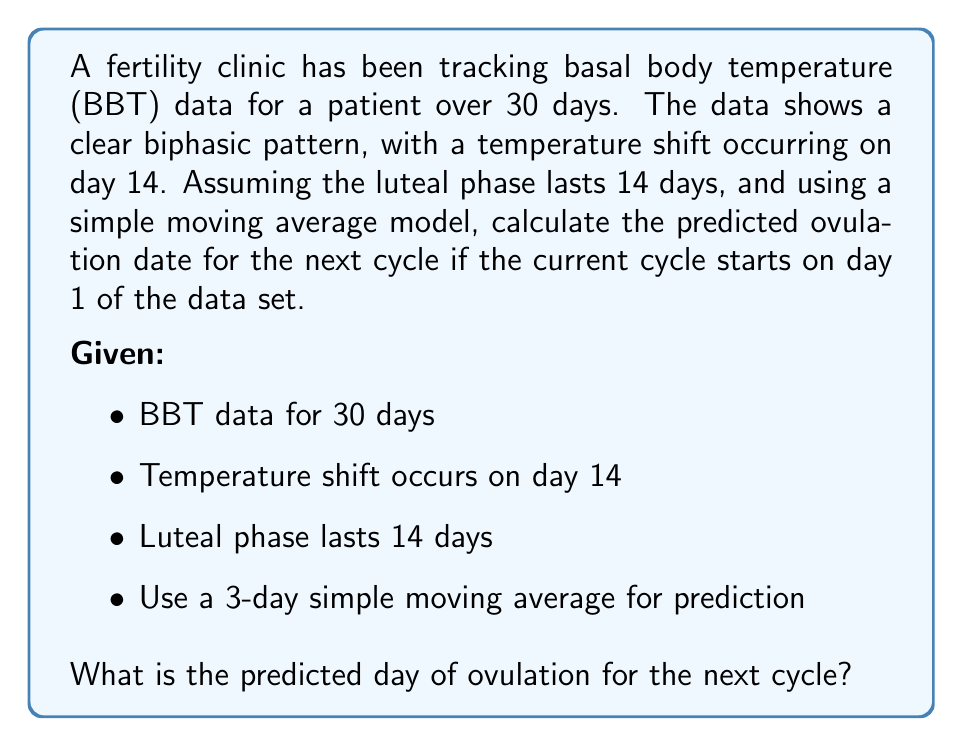What is the answer to this math problem? To solve this problem, we need to follow these steps:

1. Identify the current cycle length:
   The cycle length is the sum of the follicular phase and the luteal phase.
   Follicular phase = 14 days (until temperature shift)
   Luteal phase = 14 days (given)
   Current cycle length = 14 + 14 = 28 days

2. Calculate the 3-day simple moving average (SMA) for the last 3 days of the cycle:
   Let's assume the last 3 days' BBT readings are $T_{26}$, $T_{27}$, and $T_{28}$.
   
   $SMA = \frac{T_{26} + T_{27} + T_{28}}{3}$

3. Use the SMA to predict the next cycle's ovulation:
   The predicted ovulation day will be 14 days before the end of the next cycle.
   
   Next cycle end = Current cycle length + SMA
   Predicted ovulation day = Next cycle end - 14

4. Adjust the prediction to start from day 1 of the current cycle:
   Since we want to express the ovulation day in terms of days from the start of the current cycle, we need to add the current cycle length.

   Final predicted ovulation day = (Next cycle end - 14) + Current cycle length

Putting it all together:

$$\text{Predicted ovulation day} = (28 + \frac{T_{26} + T_{27} + T_{28}}{3} - 14) + 28$$

$$= 42 + \frac{T_{26} + T_{27} + T_{28}}{3}$$

This formula gives us the predicted ovulation day for the next cycle, counting from day 1 of the current cycle.
Answer: The predicted day of ovulation for the next cycle is:

$$42 + \frac{T_{26} + T_{27} + T_{28}}{3}$$

days from the start of the current cycle, where $T_{26}$, $T_{27}$, and $T_{28}$ are the BBT readings for the last 3 days of the current cycle. 